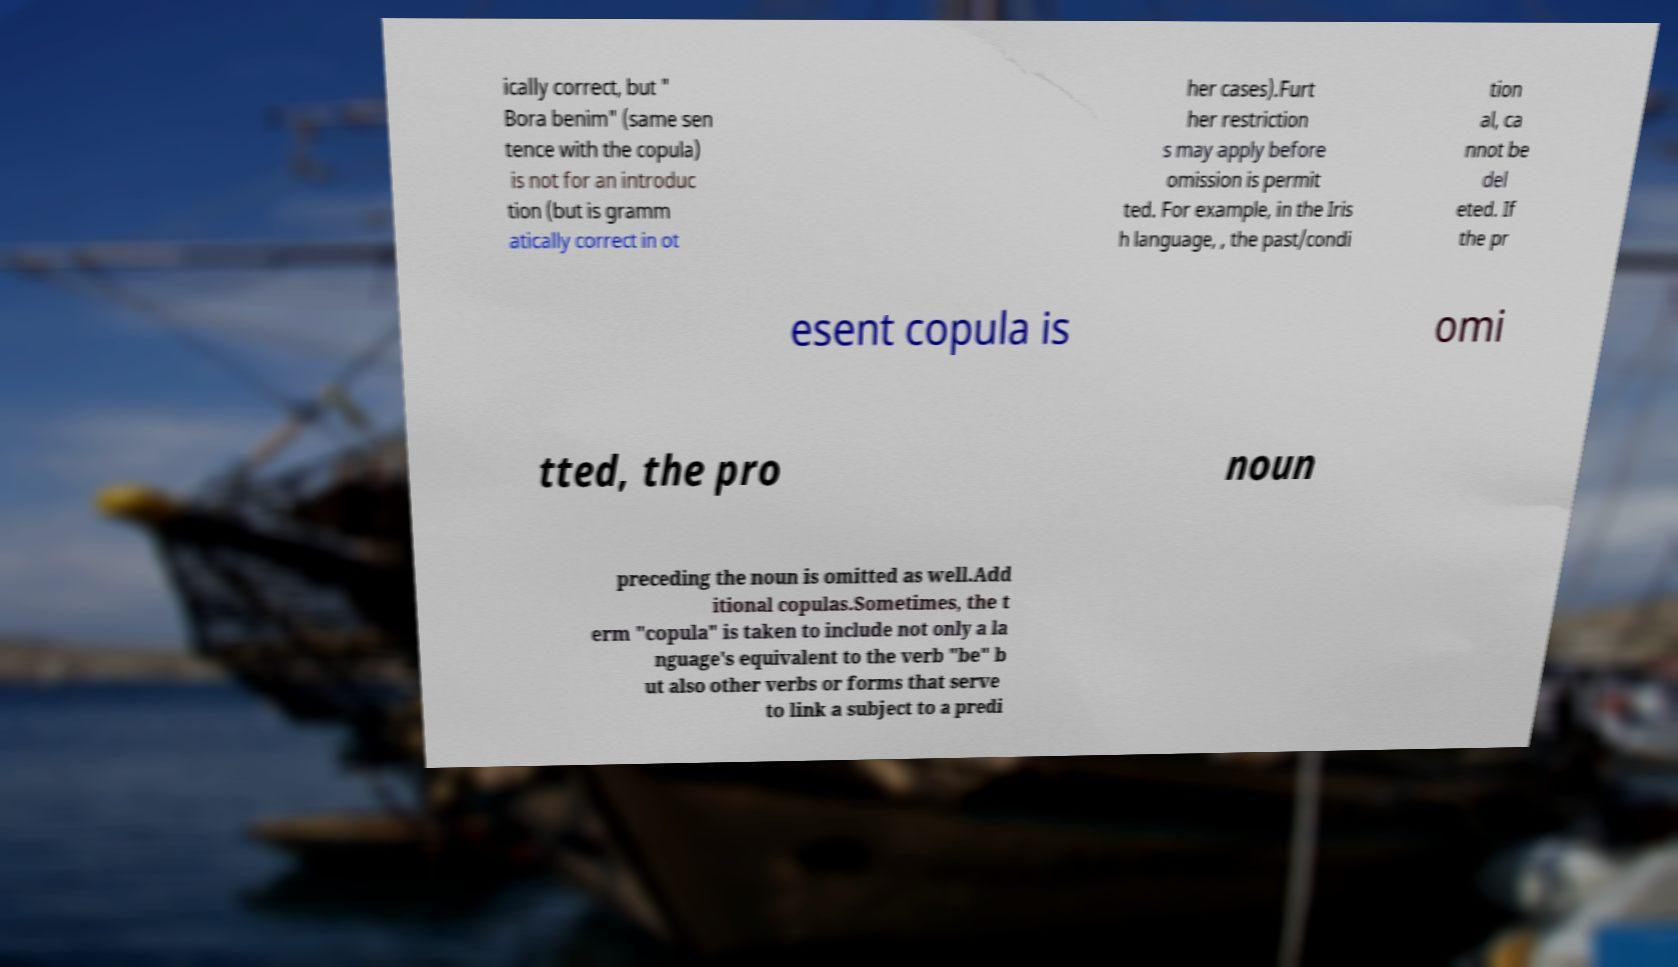I need the written content from this picture converted into text. Can you do that? ically correct, but " Bora benim" (same sen tence with the copula) is not for an introduc tion (but is gramm atically correct in ot her cases).Furt her restriction s may apply before omission is permit ted. For example, in the Iris h language, , the past/condi tion al, ca nnot be del eted. If the pr esent copula is omi tted, the pro noun preceding the noun is omitted as well.Add itional copulas.Sometimes, the t erm "copula" is taken to include not only a la nguage's equivalent to the verb "be" b ut also other verbs or forms that serve to link a subject to a predi 